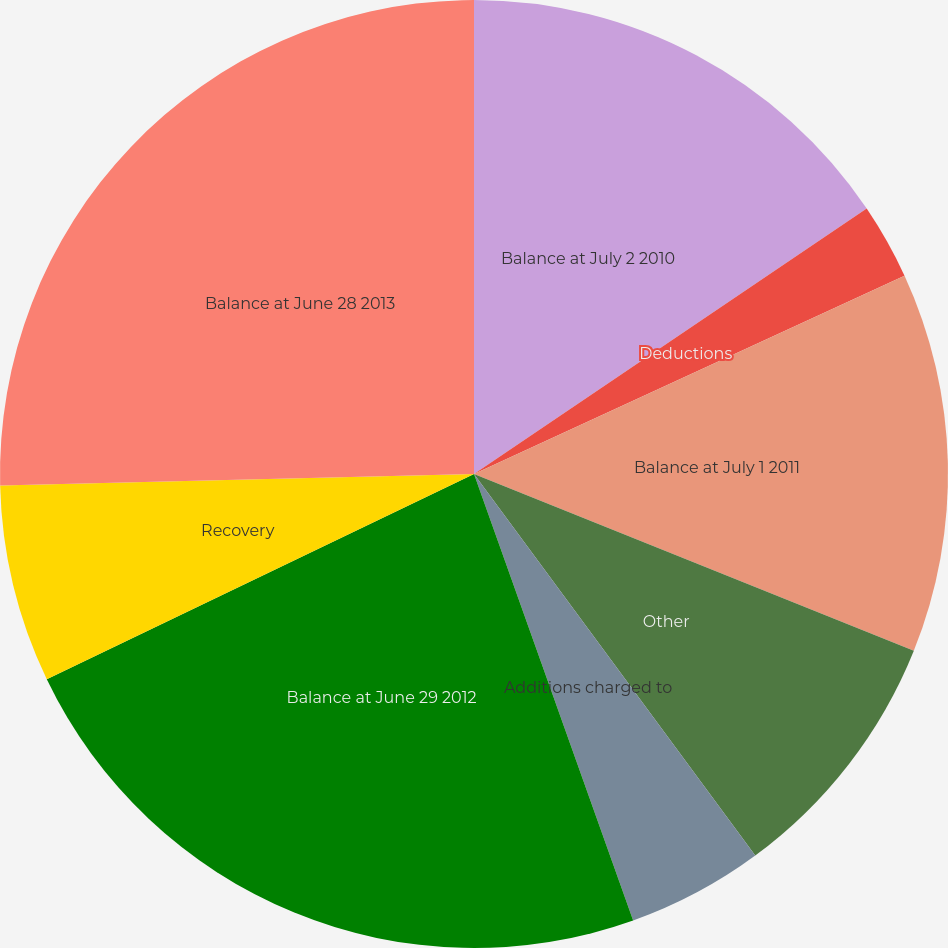<chart> <loc_0><loc_0><loc_500><loc_500><pie_chart><fcel>Balance at July 2 2010<fcel>Deductions<fcel>Balance at July 1 2011<fcel>Other<fcel>Additions charged to<fcel>Balance at June 29 2012<fcel>Recovery<fcel>Balance at June 28 2013<nl><fcel>15.54%<fcel>2.59%<fcel>12.95%<fcel>8.81%<fcel>4.66%<fcel>23.32%<fcel>6.74%<fcel>25.39%<nl></chart> 